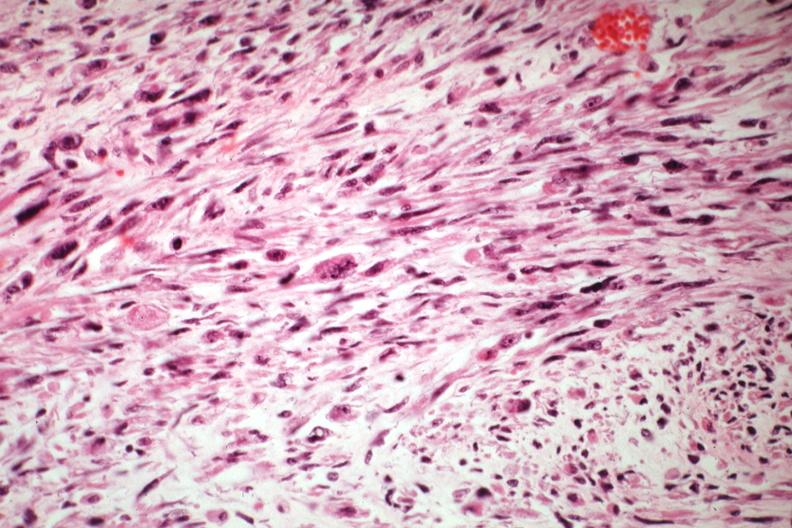does malignant adenoma show bizarre strap and fusiform cells?
Answer the question using a single word or phrase. No 